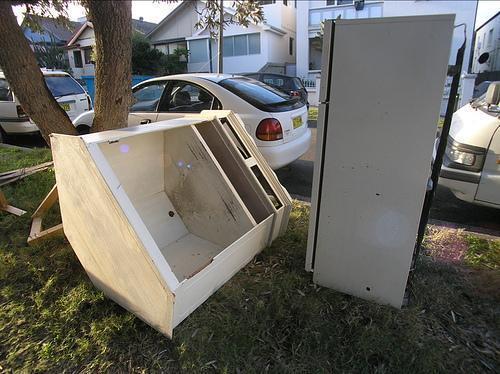How many white cars are shown?
Give a very brief answer. 3. How many cars are in the picture?
Give a very brief answer. 2. How many people in the water?
Give a very brief answer. 0. 